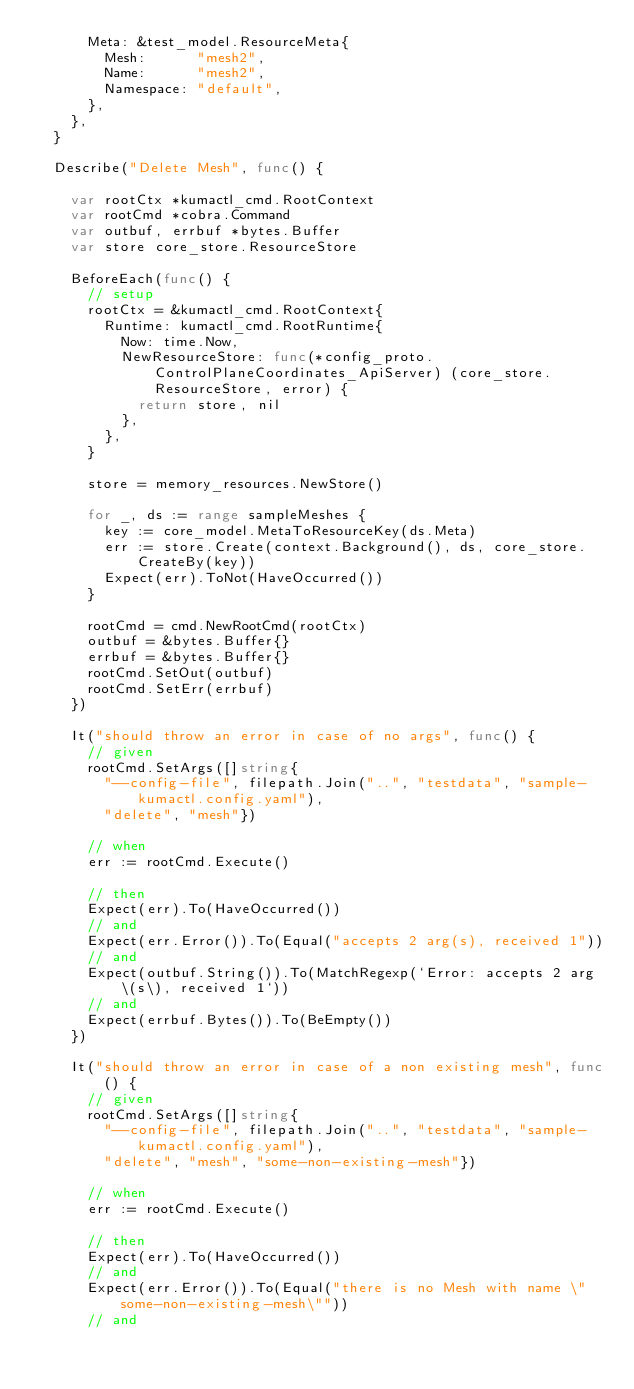Convert code to text. <code><loc_0><loc_0><loc_500><loc_500><_Go_>			Meta: &test_model.ResourceMeta{
				Mesh:      "mesh2",
				Name:      "mesh2",
				Namespace: "default",
			},
		},
	}

	Describe("Delete Mesh", func() {

		var rootCtx *kumactl_cmd.RootContext
		var rootCmd *cobra.Command
		var outbuf, errbuf *bytes.Buffer
		var store core_store.ResourceStore

		BeforeEach(func() {
			// setup
			rootCtx = &kumactl_cmd.RootContext{
				Runtime: kumactl_cmd.RootRuntime{
					Now: time.Now,
					NewResourceStore: func(*config_proto.ControlPlaneCoordinates_ApiServer) (core_store.ResourceStore, error) {
						return store, nil
					},
				},
			}

			store = memory_resources.NewStore()

			for _, ds := range sampleMeshes {
				key := core_model.MetaToResourceKey(ds.Meta)
				err := store.Create(context.Background(), ds, core_store.CreateBy(key))
				Expect(err).ToNot(HaveOccurred())
			}

			rootCmd = cmd.NewRootCmd(rootCtx)
			outbuf = &bytes.Buffer{}
			errbuf = &bytes.Buffer{}
			rootCmd.SetOut(outbuf)
			rootCmd.SetErr(errbuf)
		})

		It("should throw an error in case of no args", func() {
			// given
			rootCmd.SetArgs([]string{
				"--config-file", filepath.Join("..", "testdata", "sample-kumactl.config.yaml"),
				"delete", "mesh"})

			// when
			err := rootCmd.Execute()

			// then
			Expect(err).To(HaveOccurred())
			// and
			Expect(err.Error()).To(Equal("accepts 2 arg(s), received 1"))
			// and
			Expect(outbuf.String()).To(MatchRegexp(`Error: accepts 2 arg\(s\), received 1`))
			// and
			Expect(errbuf.Bytes()).To(BeEmpty())
		})

		It("should throw an error in case of a non existing mesh", func() {
			// given
			rootCmd.SetArgs([]string{
				"--config-file", filepath.Join("..", "testdata", "sample-kumactl.config.yaml"),
				"delete", "mesh", "some-non-existing-mesh"})

			// when
			err := rootCmd.Execute()

			// then
			Expect(err).To(HaveOccurred())
			// and
			Expect(err.Error()).To(Equal("there is no Mesh with name \"some-non-existing-mesh\""))
			// and</code> 